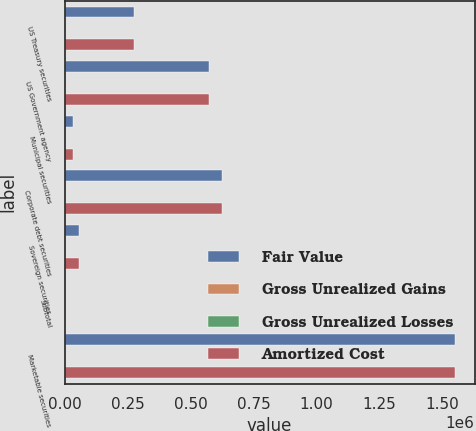Convert chart. <chart><loc_0><loc_0><loc_500><loc_500><stacked_bar_chart><ecel><fcel>US Treasury securities<fcel>US Government agency<fcel>Municipal securities<fcel>Corporate debt securities<fcel>Sovereign securities<fcel>Subtotal<fcel>Marketable securities<nl><fcel>Fair Value<fcel>274965<fcel>571843<fcel>31819<fcel>625965<fcel>57091<fcel>1707<fcel>1.54808e+06<nl><fcel>Gross Unrealized Gains<fcel>605<fcel>551<fcel>7<fcel>511<fcel>33<fcel>1707<fcel>1707<nl><fcel>Gross Unrealized Losses<fcel>15<fcel>126<fcel>10<fcel>515<fcel>31<fcel>697<fcel>697<nl><fcel>Amortized Cost<fcel>275555<fcel>572268<fcel>31816<fcel>625961<fcel>57093<fcel>1707<fcel>1.54909e+06<nl></chart> 